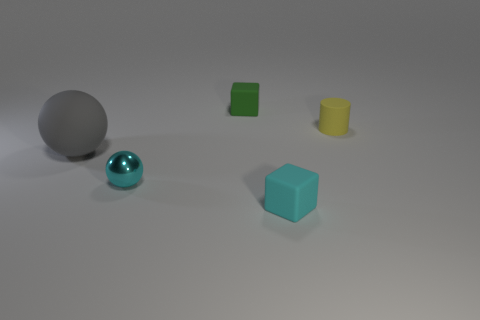Are there any other things that are the same size as the gray sphere?
Ensure brevity in your answer.  No. There is a small thing that is the same color as the shiny sphere; what is its material?
Provide a short and direct response. Rubber. Does the gray thing have the same size as the cyan cube?
Offer a terse response. No. There is a block that is in front of the cyan shiny ball; are there any gray things that are behind it?
Provide a short and direct response. Yes. There is a tiny cyan object on the right side of the small cyan sphere; what is its shape?
Your answer should be very brief. Cube. There is a cube that is in front of the large gray sphere that is to the left of the green object; what number of small cubes are on the left side of it?
Ensure brevity in your answer.  1. There is a cylinder; does it have the same size as the gray object on the left side of the small yellow rubber cylinder?
Keep it short and to the point. No. What size is the gray sphere that is in front of the matte object that is on the right side of the cyan matte object?
Offer a terse response. Large. How many other small cubes are the same material as the small green cube?
Provide a short and direct response. 1. Are any small purple rubber spheres visible?
Offer a terse response. No. 